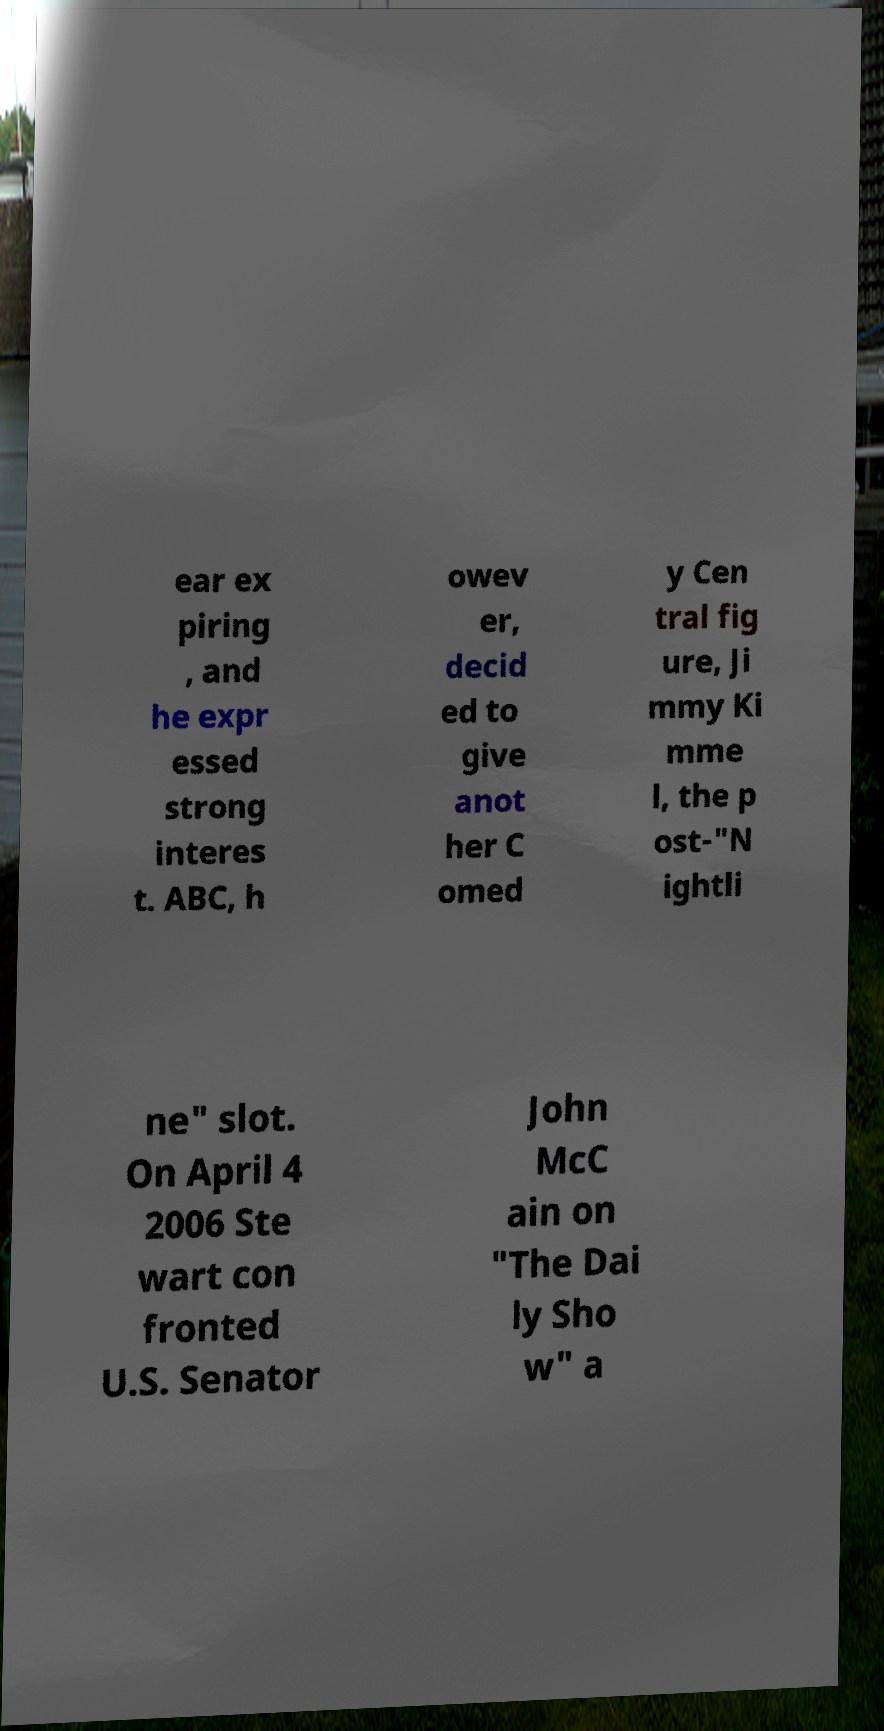Can you accurately transcribe the text from the provided image for me? ear ex piring , and he expr essed strong interes t. ABC, h owev er, decid ed to give anot her C omed y Cen tral fig ure, Ji mmy Ki mme l, the p ost-"N ightli ne" slot. On April 4 2006 Ste wart con fronted U.S. Senator John McC ain on "The Dai ly Sho w" a 